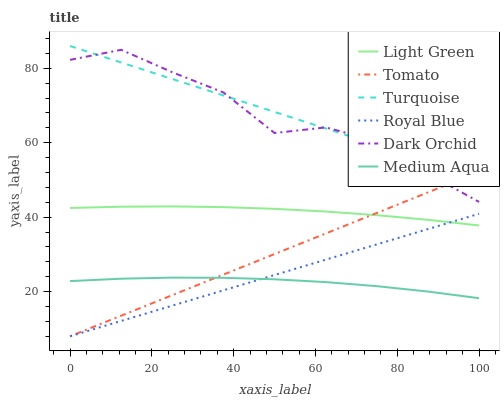Does Dark Orchid have the minimum area under the curve?
Answer yes or no. No. Does Dark Orchid have the maximum area under the curve?
Answer yes or no. No. Is Turquoise the smoothest?
Answer yes or no. No. Is Turquoise the roughest?
Answer yes or no. No. Does Dark Orchid have the lowest value?
Answer yes or no. No. Does Dark Orchid have the highest value?
Answer yes or no. No. Is Royal Blue less than Turquoise?
Answer yes or no. Yes. Is Turquoise greater than Royal Blue?
Answer yes or no. Yes. Does Royal Blue intersect Turquoise?
Answer yes or no. No. 